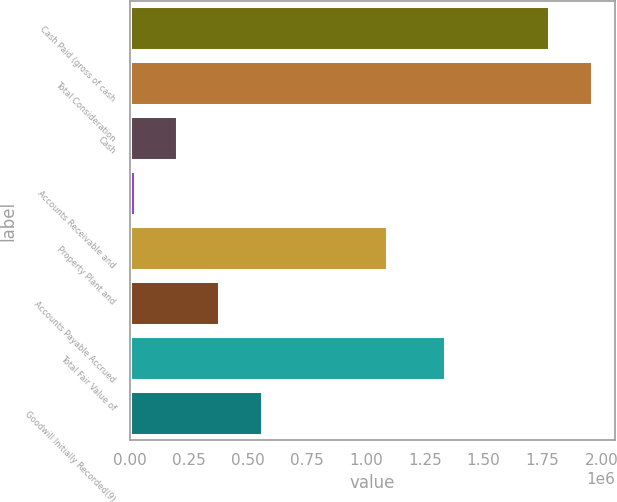Convert chart to OTSL. <chart><loc_0><loc_0><loc_500><loc_500><bar_chart><fcel>Cash Paid (gross of cash<fcel>Total Consideration<fcel>Cash<fcel>Accounts Receivable and<fcel>Property Plant and<fcel>Accounts Payable Accrued<fcel>Total Fair Value of<fcel>Goodwill Initially Recorded(9)<nl><fcel>1.77912e+06<fcel>1.95854e+06<fcel>199566<fcel>20146<fcel>1.08888e+06<fcel>378985<fcel>1.33674e+06<fcel>558405<nl></chart> 